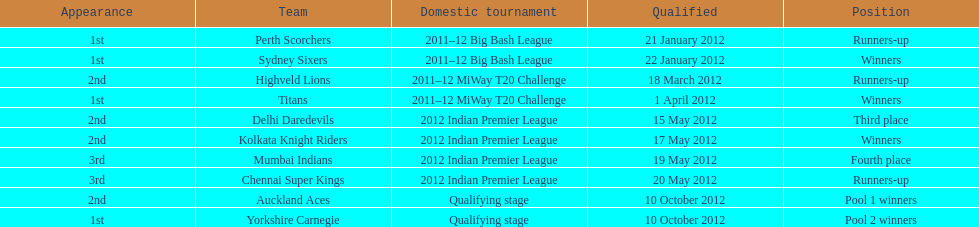Did the titans or the daredevils winners? Titans. 